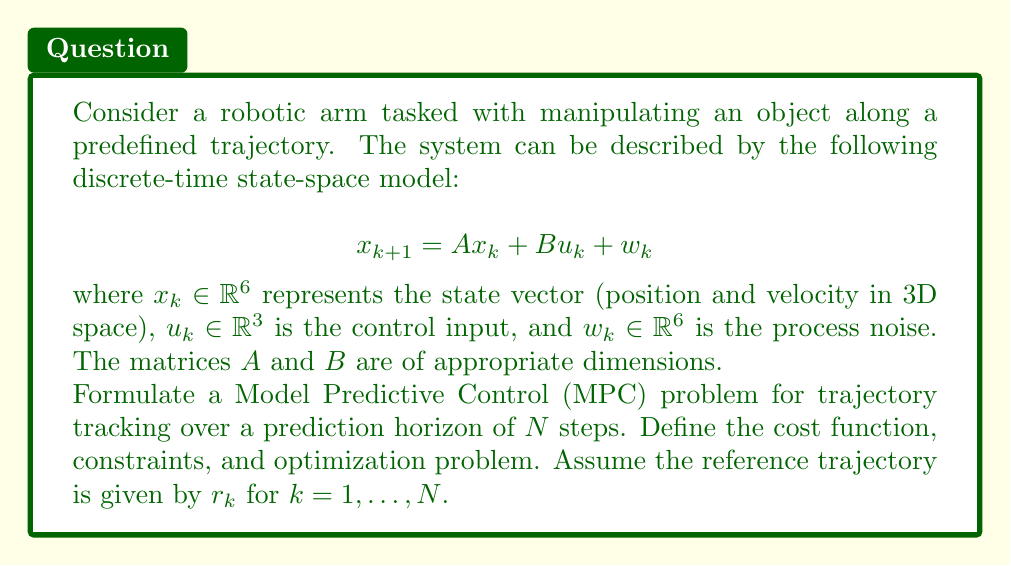Could you help me with this problem? To formulate the MPC problem for trajectory tracking in object manipulation, we need to define the cost function, constraints, and optimization problem. Let's break this down step-by-step:

1. Cost Function:
   The cost function typically includes terms for state tracking error, control effort, and possibly terminal cost. We can define it as:

   $$
   J = \sum_{k=0}^{N-1} \left[(x_k - r_k)^T Q (x_k - r_k) + u_k^T R u_k\right] + (x_N - r_N)^T P (x_N - r_N)
   $$

   where $Q \succeq 0$, $R \succ 0$, and $P \succeq 0$ are weighting matrices for state tracking error, control effort, and terminal cost, respectively.

2. Constraints:
   We need to consider state and input constraints:

   a. State constraints: $x_k \in \mathcal{X}$, where $\mathcal{X}$ is the feasible state space.
   b. Input constraints: $u_k \in \mathcal{U}$, where $\mathcal{U}$ is the set of admissible control inputs.

3. System Dynamics:
   The system evolution is governed by the state-space model:

   $$
   x_{k+1} = Ax_k + Bu_k + w_k
   $$

4. Optimization Problem:
   The MPC optimization problem can be formulated as:

   $$
   \begin{aligned}
   \min_{u_0, \ldots, u_{N-1}} \quad & J = \sum_{k=0}^{N-1} \left[(x_k - r_k)^T Q (x_k - r_k) + u_k^T R u_k\right] + (x_N - r_N)^T P (x_N - r_N) \\
   \text{subject to} \quad & x_{k+1} = Ax_k + Bu_k + w_k, \quad k = 0, \ldots, N-1 \\
   & x_k \in \mathcal{X}, \quad k = 1, \ldots, N \\
   & u_k \in \mathcal{U}, \quad k = 0, \ldots, N-1 \\
   & x_0 = x(t)
   \end{aligned}
   $$

   where $x(t)$ is the current state measurement.

5. Receding Horizon Implementation:
   After solving the optimization problem, only the first control input $u_0$ is applied to the system. The process is then repeated at the next time step with updated state information.

This formulation allows for trajectory tracking while considering system dynamics, constraints, and optimizing performance over a finite horizon.
Answer: The MPC problem for trajectory tracking in object manipulation is formulated as:

$$
\begin{aligned}
\min_{u_0, \ldots, u_{N-1}} \quad & J = \sum_{k=0}^{N-1} \left[(x_k - r_k)^T Q (x_k - r_k) + u_k^T R u_k\right] + (x_N - r_N)^T P (x_N - r_N) \\
\text{subject to} \quad & x_{k+1} = Ax_k + Bu_k + w_k, \quad k = 0, \ldots, N-1 \\
& x_k \in \mathcal{X}, \quad k = 1, \ldots, N \\
& u_k \in \mathcal{U}, \quad k = 0, \ldots, N-1 \\
& x_0 = x(t)
\end{aligned}
$$

where $x_k \in \mathbb{R}^6$ is the state vector, $u_k \in \mathbb{R}^3$ is the control input, $r_k$ is the reference trajectory, $Q \succeq 0$, $R \succ 0$, and $P \succeq 0$ are weighting matrices, and $\mathcal{X}$ and $\mathcal{U}$ are the feasible state and input sets, respectively. 